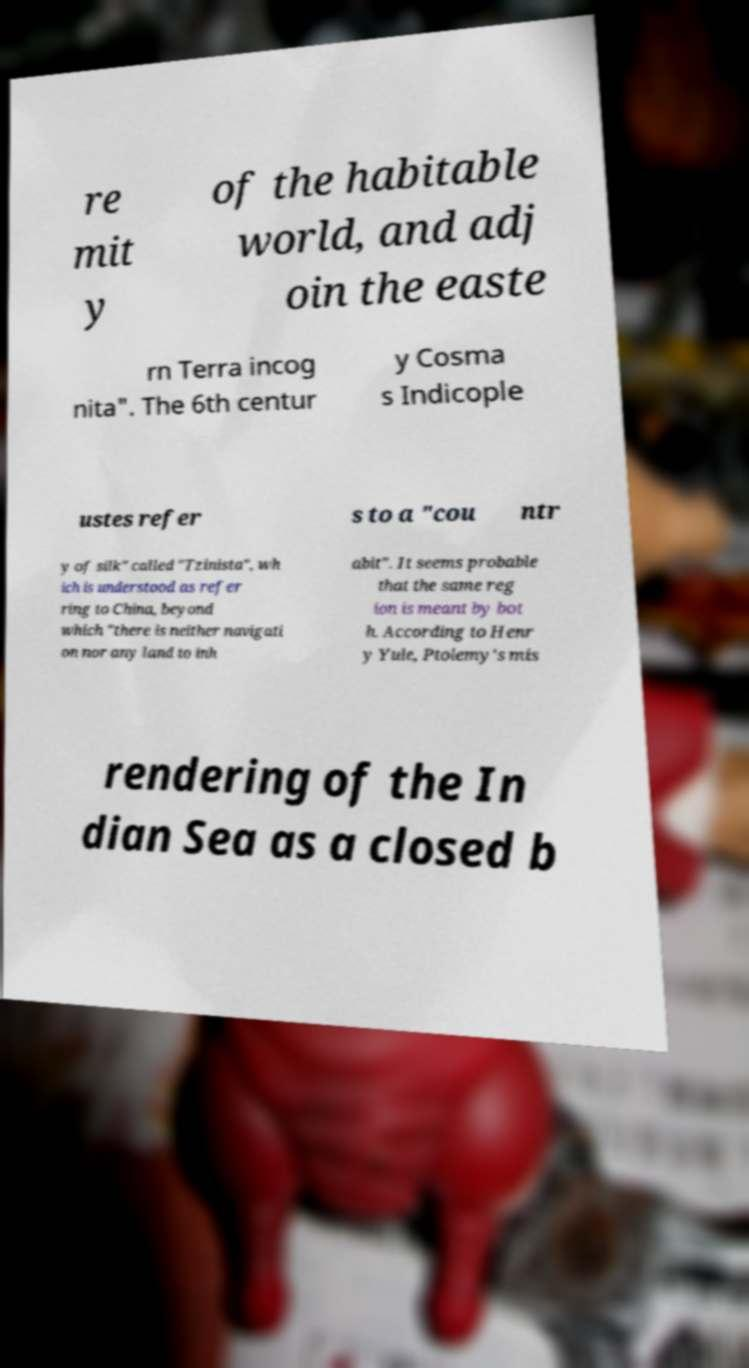Could you assist in decoding the text presented in this image and type it out clearly? re mit y of the habitable world, and adj oin the easte rn Terra incog nita". The 6th centur y Cosma s Indicople ustes refer s to a "cou ntr y of silk" called "Tzinista", wh ich is understood as refer ring to China, beyond which "there is neither navigati on nor any land to inh abit". It seems probable that the same reg ion is meant by bot h. According to Henr y Yule, Ptolemy's mis rendering of the In dian Sea as a closed b 